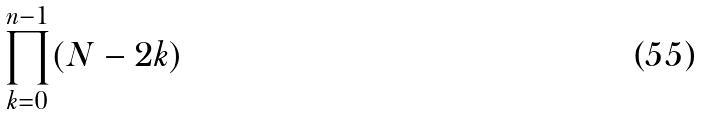Convert formula to latex. <formula><loc_0><loc_0><loc_500><loc_500>\prod _ { k = 0 } ^ { n - 1 } ( N - 2 k )</formula> 